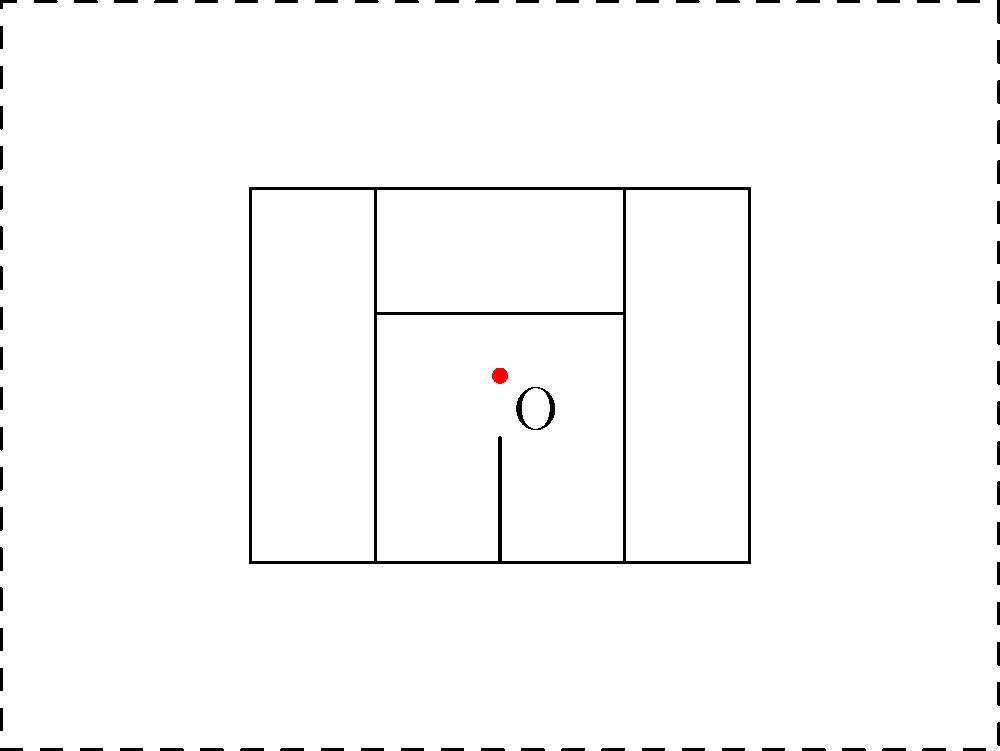Hey buddy, remember when we used to draw silly houses during math class? Well, check out this cool house drawing! If we scale it up from the center point O by a factor of 2, how far will point A move from its original position? Alright, let's break this down step-by-step, just like we used to do with our secret codes:

1) First, we need to find the coordinates of point A. In this drawing, A is at (0,0).

2) The center point O is at (2,1.5).

3) When we scale from a center point, each point moves along a line from the center through the original point. The distance from the center to the new point is the scale factor times the original distance.

4) To find where A moves to (let's call it A'), we can use this formula:
   $A' = O + 2(A - O)$

5) Let's calculate:
   $A' = (2,1.5) + 2((0,0) - (2,1.5))$
   $A' = (2,1.5) + 2(-2,-1.5)$
   $A' = (2,1.5) + (-4,-3)$
   $A' = (-2,-1.5)$

6) Now, to find how far A moved, we need to calculate the distance between A (0,0) and A' (-2,-1.5):
   Distance = $\sqrt{(-2-0)^2 + (-1.5-0)^2}$
   $= \sqrt{(-2)^2 + (-1.5)^2}$
   $= \sqrt{4 + 2.25}$
   $= \sqrt{6.25}$
   $= 2.5$

So, point A moves 2.5 units from its original position.
Answer: 2.5 units 